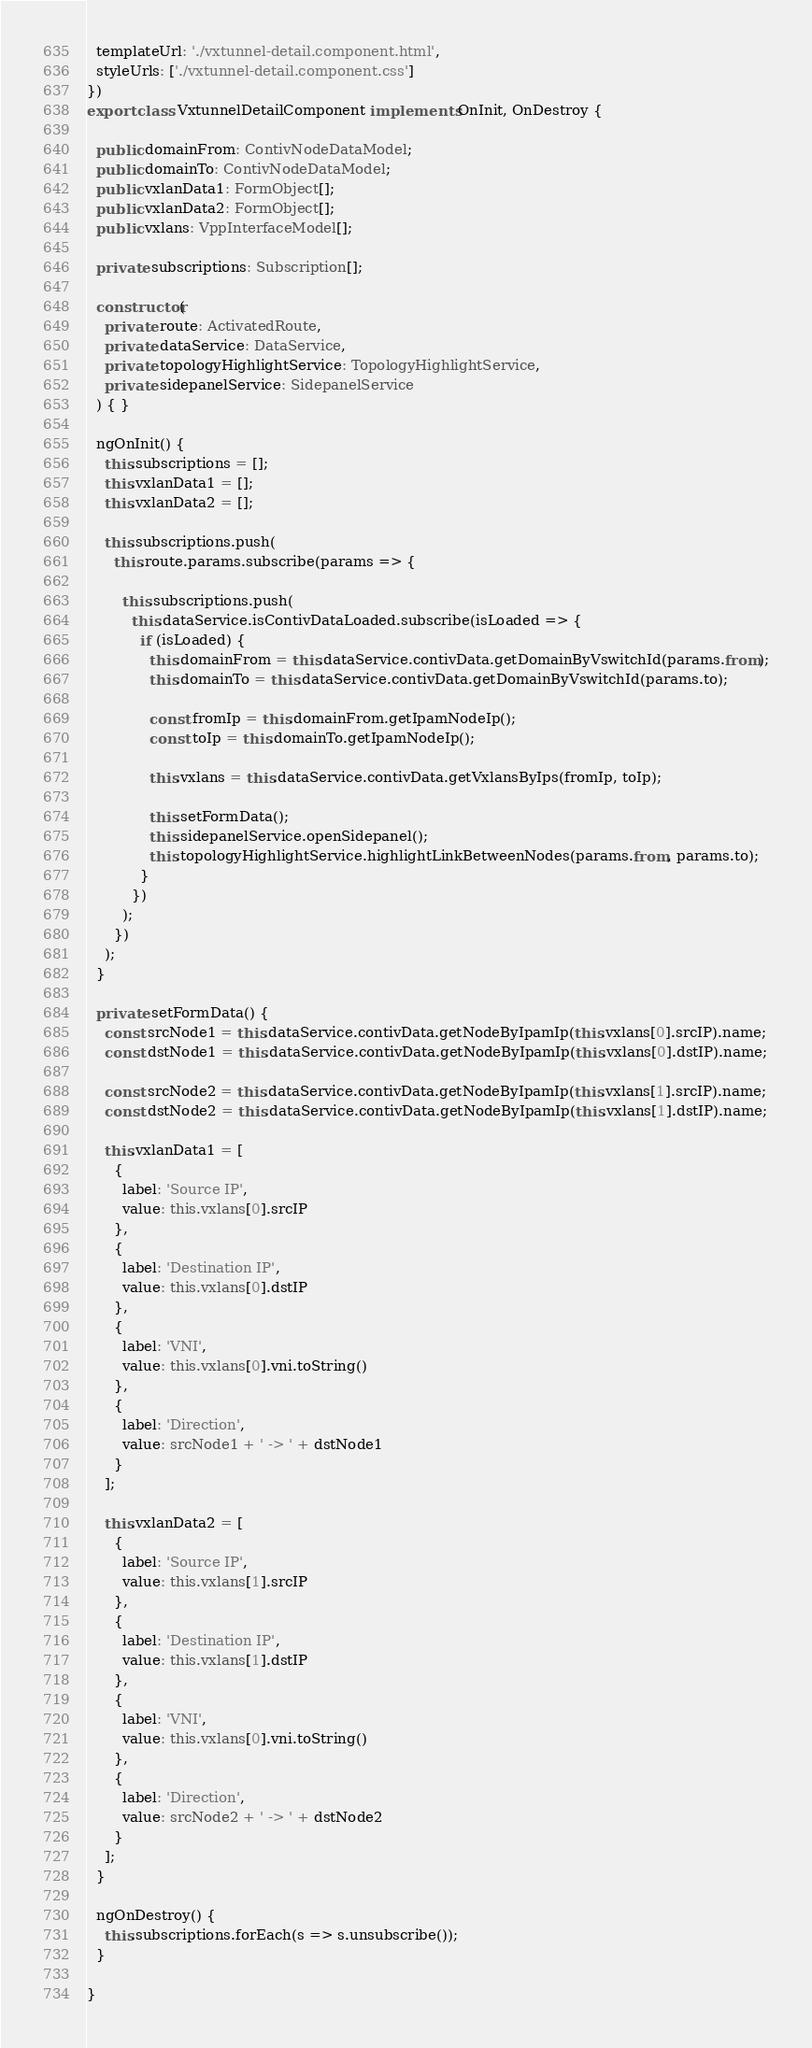<code> <loc_0><loc_0><loc_500><loc_500><_TypeScript_>  templateUrl: './vxtunnel-detail.component.html',
  styleUrls: ['./vxtunnel-detail.component.css']
})
export class VxtunnelDetailComponent implements OnInit, OnDestroy {

  public domainFrom: ContivNodeDataModel;
  public domainTo: ContivNodeDataModel;
  public vxlanData1: FormObject[];
  public vxlanData2: FormObject[];
  public vxlans: VppInterfaceModel[];

  private subscriptions: Subscription[];

  constructor(
    private route: ActivatedRoute,
    private dataService: DataService,
    private topologyHighlightService: TopologyHighlightService,
    private sidepanelService: SidepanelService
  ) { }

  ngOnInit() {
    this.subscriptions = [];
    this.vxlanData1 = [];
    this.vxlanData2 = [];

    this.subscriptions.push(
      this.route.params.subscribe(params => {

        this.subscriptions.push(
          this.dataService.isContivDataLoaded.subscribe(isLoaded => {
            if (isLoaded) {
              this.domainFrom = this.dataService.contivData.getDomainByVswitchId(params.from);
              this.domainTo = this.dataService.contivData.getDomainByVswitchId(params.to);

              const fromIp = this.domainFrom.getIpamNodeIp();
              const toIp = this.domainTo.getIpamNodeIp();

              this.vxlans = this.dataService.contivData.getVxlansByIps(fromIp, toIp);

              this.setFormData();
              this.sidepanelService.openSidepanel();
              this.topologyHighlightService.highlightLinkBetweenNodes(params.from, params.to);
            }
          })
        );
      })
    );
  }

  private setFormData() {
    const srcNode1 = this.dataService.contivData.getNodeByIpamIp(this.vxlans[0].srcIP).name;
    const dstNode1 = this.dataService.contivData.getNodeByIpamIp(this.vxlans[0].dstIP).name;

    const srcNode2 = this.dataService.contivData.getNodeByIpamIp(this.vxlans[1].srcIP).name;
    const dstNode2 = this.dataService.contivData.getNodeByIpamIp(this.vxlans[1].dstIP).name;

    this.vxlanData1 = [
      {
        label: 'Source IP',
        value: this.vxlans[0].srcIP
      },
      {
        label: 'Destination IP',
        value: this.vxlans[0].dstIP
      },
      {
        label: 'VNI',
        value: this.vxlans[0].vni.toString()
      },
      {
        label: 'Direction',
        value: srcNode1 + ' -> ' + dstNode1
      }
    ];

    this.vxlanData2 = [
      {
        label: 'Source IP',
        value: this.vxlans[1].srcIP
      },
      {
        label: 'Destination IP',
        value: this.vxlans[1].dstIP
      },
      {
        label: 'VNI',
        value: this.vxlans[0].vni.toString()
      },
      {
        label: 'Direction',
        value: srcNode2 + ' -> ' + dstNode2
      }
    ];
  }

  ngOnDestroy() {
    this.subscriptions.forEach(s => s.unsubscribe());
  }

}
</code> 